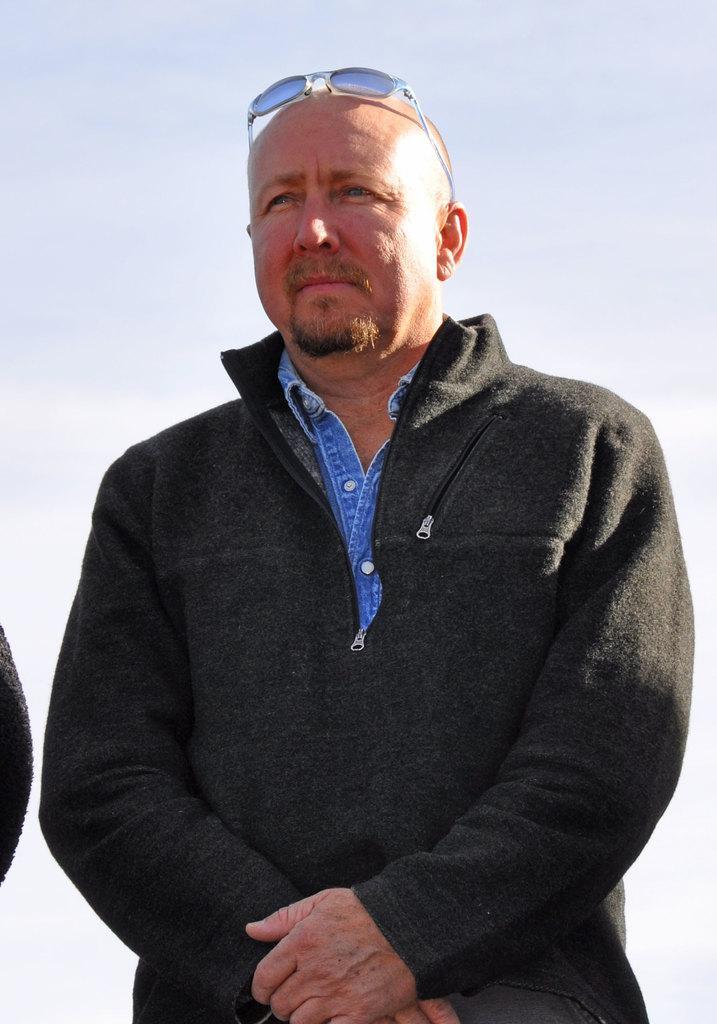Can you describe this image briefly? In the center of the image, we can see a person standing and wearing a coat and glasses and we can see an other person. In the background, there is sky. 